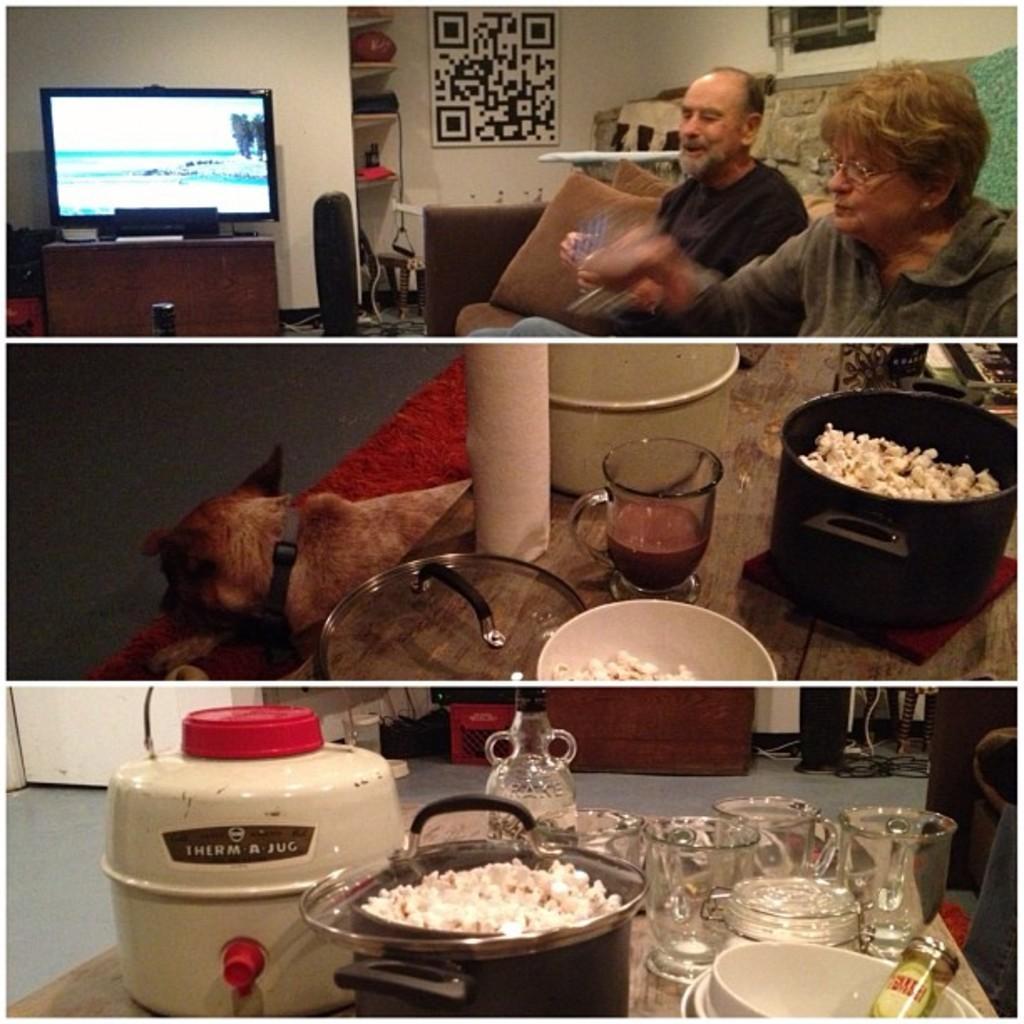Please provide a concise description of this image. There are three images. In the first image, there are two persons sitting on a sofa. Beside them, there is a television on a table. In the background, there is a white wall and other objects. In the second image, there are popcorn on a vessel, besides this, there is a glass and other objects on the table. Under this table, there is a dog. In the third image, there is a tin, there are glasses, a jug, popcorn on a plate which is on a vessel and other objects on the table. In the background, there is a floor and a white wall. 